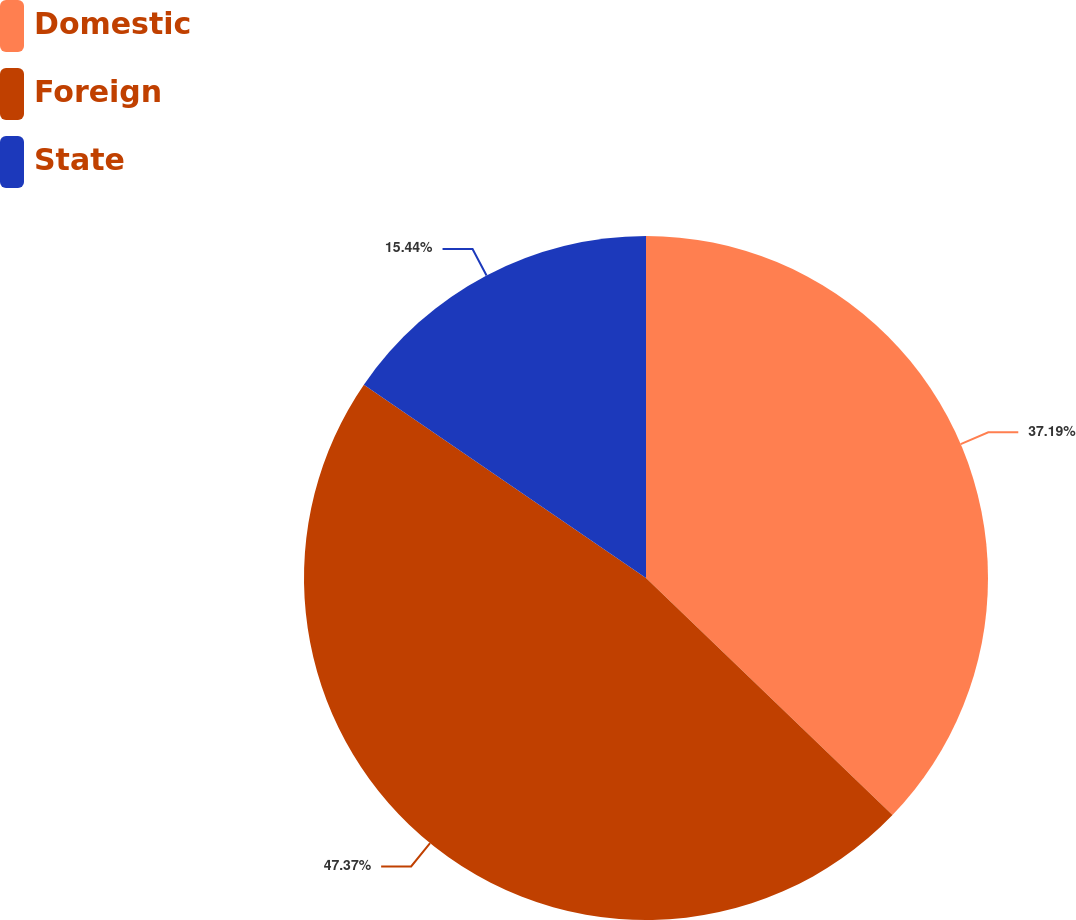<chart> <loc_0><loc_0><loc_500><loc_500><pie_chart><fcel>Domestic<fcel>Foreign<fcel>State<nl><fcel>37.19%<fcel>47.37%<fcel>15.44%<nl></chart> 